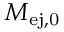<formula> <loc_0><loc_0><loc_500><loc_500>M _ { e j , 0 }</formula> 